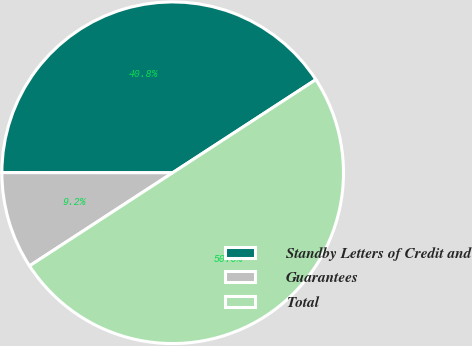Convert chart to OTSL. <chart><loc_0><loc_0><loc_500><loc_500><pie_chart><fcel>Standby Letters of Credit and<fcel>Guarantees<fcel>Total<nl><fcel>40.81%<fcel>9.19%<fcel>50.0%<nl></chart> 